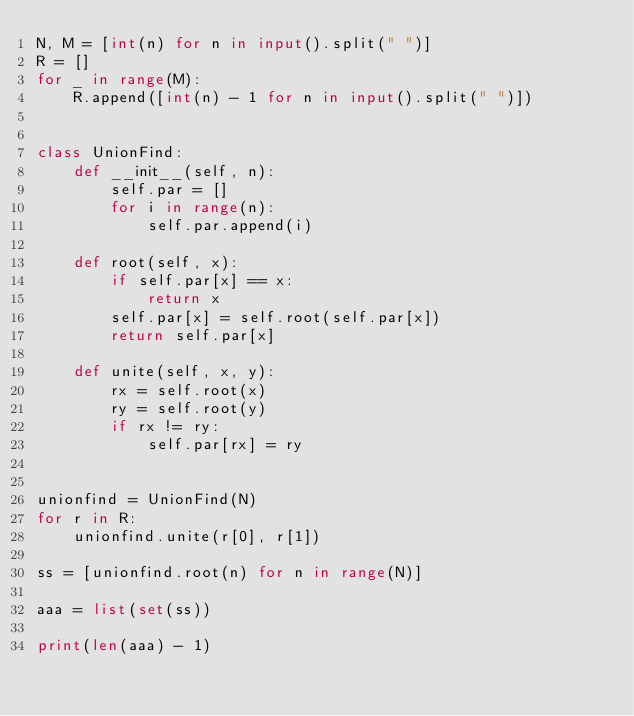Convert code to text. <code><loc_0><loc_0><loc_500><loc_500><_Python_>N, M = [int(n) for n in input().split(" ")]
R = []
for _ in range(M):
    R.append([int(n) - 1 for n in input().split(" ")])


class UnionFind:
    def __init__(self, n):
        self.par = []
        for i in range(n):
            self.par.append(i)

    def root(self, x):
        if self.par[x] == x:
            return x
        self.par[x] = self.root(self.par[x])
        return self.par[x]

    def unite(self, x, y):
        rx = self.root(x)
        ry = self.root(y)
        if rx != ry:
            self.par[rx] = ry


unionfind = UnionFind(N)
for r in R:
    unionfind.unite(r[0], r[1])

ss = [unionfind.root(n) for n in range(N)]

aaa = list(set(ss))

print(len(aaa) - 1)
    


</code> 